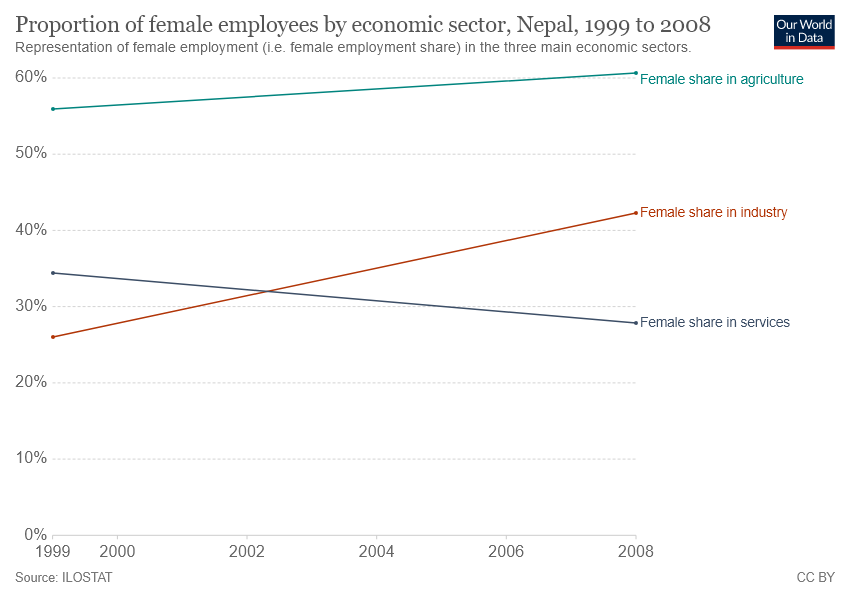Give some essential details in this illustration. In 2008, the gap between the value of female participation in agriculture and female participation in services reached its largest disparity. The number of lines included in the graph is 3. 